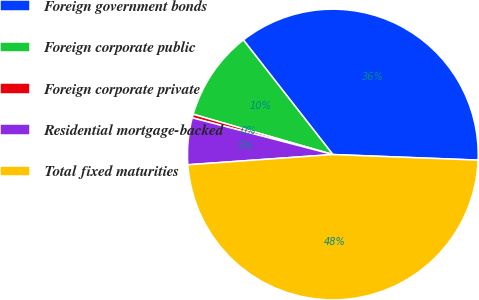Convert chart. <chart><loc_0><loc_0><loc_500><loc_500><pie_chart><fcel>Foreign government bonds<fcel>Foreign corporate public<fcel>Foreign corporate private<fcel>Residential mortgage-backed<fcel>Total fixed maturities<nl><fcel>36.17%<fcel>9.98%<fcel>0.4%<fcel>5.19%<fcel>48.27%<nl></chart> 